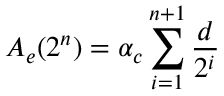Convert formula to latex. <formula><loc_0><loc_0><loc_500><loc_500>A _ { e } ( 2 ^ { n } ) = \alpha _ { c } \sum _ { i = 1 } ^ { n + 1 } \frac { d } { 2 ^ { i } }</formula> 